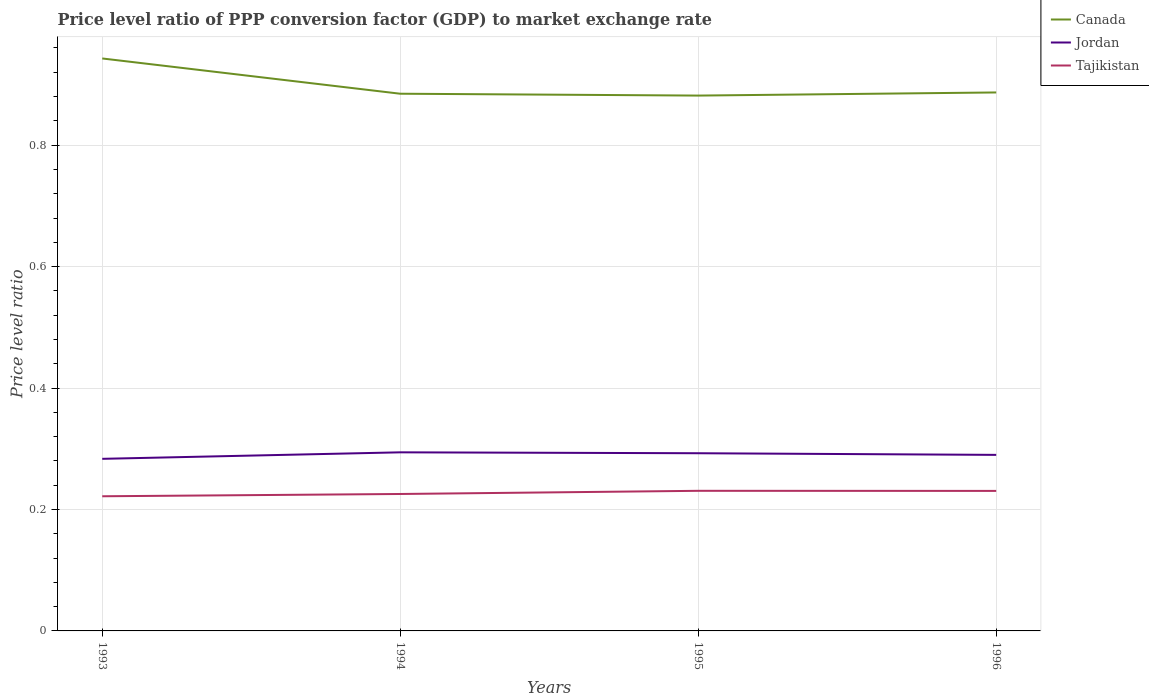Across all years, what is the maximum price level ratio in Jordan?
Your answer should be compact. 0.28. What is the total price level ratio in Canada in the graph?
Give a very brief answer. 0.06. What is the difference between the highest and the second highest price level ratio in Canada?
Offer a very short reply. 0.06. What is the difference between the highest and the lowest price level ratio in Canada?
Offer a very short reply. 1. How many lines are there?
Give a very brief answer. 3. How many years are there in the graph?
Provide a succinct answer. 4. What is the difference between two consecutive major ticks on the Y-axis?
Offer a very short reply. 0.2. Are the values on the major ticks of Y-axis written in scientific E-notation?
Provide a short and direct response. No. Where does the legend appear in the graph?
Give a very brief answer. Top right. How many legend labels are there?
Make the answer very short. 3. What is the title of the graph?
Your answer should be very brief. Price level ratio of PPP conversion factor (GDP) to market exchange rate. What is the label or title of the Y-axis?
Offer a terse response. Price level ratio. What is the Price level ratio in Canada in 1993?
Give a very brief answer. 0.94. What is the Price level ratio of Jordan in 1993?
Offer a terse response. 0.28. What is the Price level ratio of Tajikistan in 1993?
Provide a succinct answer. 0.22. What is the Price level ratio of Canada in 1994?
Your response must be concise. 0.88. What is the Price level ratio in Jordan in 1994?
Provide a short and direct response. 0.29. What is the Price level ratio of Tajikistan in 1994?
Offer a very short reply. 0.23. What is the Price level ratio in Canada in 1995?
Your answer should be very brief. 0.88. What is the Price level ratio of Jordan in 1995?
Make the answer very short. 0.29. What is the Price level ratio in Tajikistan in 1995?
Provide a short and direct response. 0.23. What is the Price level ratio in Canada in 1996?
Provide a succinct answer. 0.89. What is the Price level ratio in Jordan in 1996?
Give a very brief answer. 0.29. What is the Price level ratio in Tajikistan in 1996?
Provide a succinct answer. 0.23. Across all years, what is the maximum Price level ratio in Canada?
Provide a short and direct response. 0.94. Across all years, what is the maximum Price level ratio in Jordan?
Offer a very short reply. 0.29. Across all years, what is the maximum Price level ratio in Tajikistan?
Ensure brevity in your answer.  0.23. Across all years, what is the minimum Price level ratio in Canada?
Offer a very short reply. 0.88. Across all years, what is the minimum Price level ratio in Jordan?
Provide a short and direct response. 0.28. Across all years, what is the minimum Price level ratio of Tajikistan?
Your answer should be very brief. 0.22. What is the total Price level ratio in Canada in the graph?
Your answer should be compact. 3.6. What is the total Price level ratio of Jordan in the graph?
Your answer should be very brief. 1.16. What is the total Price level ratio of Tajikistan in the graph?
Your answer should be compact. 0.91. What is the difference between the Price level ratio in Canada in 1993 and that in 1994?
Offer a very short reply. 0.06. What is the difference between the Price level ratio in Jordan in 1993 and that in 1994?
Your answer should be very brief. -0.01. What is the difference between the Price level ratio in Tajikistan in 1993 and that in 1994?
Offer a terse response. -0. What is the difference between the Price level ratio of Canada in 1993 and that in 1995?
Your answer should be compact. 0.06. What is the difference between the Price level ratio of Jordan in 1993 and that in 1995?
Make the answer very short. -0.01. What is the difference between the Price level ratio in Tajikistan in 1993 and that in 1995?
Your answer should be very brief. -0.01. What is the difference between the Price level ratio in Canada in 1993 and that in 1996?
Offer a very short reply. 0.06. What is the difference between the Price level ratio of Jordan in 1993 and that in 1996?
Offer a terse response. -0.01. What is the difference between the Price level ratio in Tajikistan in 1993 and that in 1996?
Make the answer very short. -0.01. What is the difference between the Price level ratio of Canada in 1994 and that in 1995?
Provide a short and direct response. 0. What is the difference between the Price level ratio in Jordan in 1994 and that in 1995?
Give a very brief answer. 0. What is the difference between the Price level ratio of Tajikistan in 1994 and that in 1995?
Provide a succinct answer. -0.01. What is the difference between the Price level ratio in Canada in 1994 and that in 1996?
Provide a short and direct response. -0. What is the difference between the Price level ratio in Jordan in 1994 and that in 1996?
Provide a succinct answer. 0. What is the difference between the Price level ratio in Tajikistan in 1994 and that in 1996?
Your answer should be very brief. -0.01. What is the difference between the Price level ratio of Canada in 1995 and that in 1996?
Give a very brief answer. -0.01. What is the difference between the Price level ratio of Jordan in 1995 and that in 1996?
Your response must be concise. 0. What is the difference between the Price level ratio of Tajikistan in 1995 and that in 1996?
Provide a succinct answer. 0. What is the difference between the Price level ratio in Canada in 1993 and the Price level ratio in Jordan in 1994?
Give a very brief answer. 0.65. What is the difference between the Price level ratio in Canada in 1993 and the Price level ratio in Tajikistan in 1994?
Keep it short and to the point. 0.72. What is the difference between the Price level ratio of Jordan in 1993 and the Price level ratio of Tajikistan in 1994?
Provide a short and direct response. 0.06. What is the difference between the Price level ratio of Canada in 1993 and the Price level ratio of Jordan in 1995?
Your answer should be compact. 0.65. What is the difference between the Price level ratio of Canada in 1993 and the Price level ratio of Tajikistan in 1995?
Your response must be concise. 0.71. What is the difference between the Price level ratio of Jordan in 1993 and the Price level ratio of Tajikistan in 1995?
Keep it short and to the point. 0.05. What is the difference between the Price level ratio in Canada in 1993 and the Price level ratio in Jordan in 1996?
Your response must be concise. 0.65. What is the difference between the Price level ratio of Canada in 1993 and the Price level ratio of Tajikistan in 1996?
Your response must be concise. 0.71. What is the difference between the Price level ratio in Jordan in 1993 and the Price level ratio in Tajikistan in 1996?
Your answer should be very brief. 0.05. What is the difference between the Price level ratio of Canada in 1994 and the Price level ratio of Jordan in 1995?
Offer a terse response. 0.59. What is the difference between the Price level ratio in Canada in 1994 and the Price level ratio in Tajikistan in 1995?
Provide a short and direct response. 0.65. What is the difference between the Price level ratio of Jordan in 1994 and the Price level ratio of Tajikistan in 1995?
Your answer should be very brief. 0.06. What is the difference between the Price level ratio in Canada in 1994 and the Price level ratio in Jordan in 1996?
Your response must be concise. 0.59. What is the difference between the Price level ratio of Canada in 1994 and the Price level ratio of Tajikistan in 1996?
Provide a short and direct response. 0.65. What is the difference between the Price level ratio of Jordan in 1994 and the Price level ratio of Tajikistan in 1996?
Provide a short and direct response. 0.06. What is the difference between the Price level ratio in Canada in 1995 and the Price level ratio in Jordan in 1996?
Make the answer very short. 0.59. What is the difference between the Price level ratio of Canada in 1995 and the Price level ratio of Tajikistan in 1996?
Your response must be concise. 0.65. What is the difference between the Price level ratio in Jordan in 1995 and the Price level ratio in Tajikistan in 1996?
Provide a succinct answer. 0.06. What is the average Price level ratio of Canada per year?
Your answer should be compact. 0.9. What is the average Price level ratio in Jordan per year?
Make the answer very short. 0.29. What is the average Price level ratio in Tajikistan per year?
Your response must be concise. 0.23. In the year 1993, what is the difference between the Price level ratio in Canada and Price level ratio in Jordan?
Offer a terse response. 0.66. In the year 1993, what is the difference between the Price level ratio of Canada and Price level ratio of Tajikistan?
Ensure brevity in your answer.  0.72. In the year 1993, what is the difference between the Price level ratio of Jordan and Price level ratio of Tajikistan?
Offer a terse response. 0.06. In the year 1994, what is the difference between the Price level ratio of Canada and Price level ratio of Jordan?
Provide a short and direct response. 0.59. In the year 1994, what is the difference between the Price level ratio in Canada and Price level ratio in Tajikistan?
Your answer should be compact. 0.66. In the year 1994, what is the difference between the Price level ratio of Jordan and Price level ratio of Tajikistan?
Your answer should be compact. 0.07. In the year 1995, what is the difference between the Price level ratio in Canada and Price level ratio in Jordan?
Keep it short and to the point. 0.59. In the year 1995, what is the difference between the Price level ratio of Canada and Price level ratio of Tajikistan?
Offer a very short reply. 0.65. In the year 1995, what is the difference between the Price level ratio in Jordan and Price level ratio in Tajikistan?
Your answer should be compact. 0.06. In the year 1996, what is the difference between the Price level ratio in Canada and Price level ratio in Jordan?
Provide a short and direct response. 0.6. In the year 1996, what is the difference between the Price level ratio of Canada and Price level ratio of Tajikistan?
Ensure brevity in your answer.  0.66. In the year 1996, what is the difference between the Price level ratio in Jordan and Price level ratio in Tajikistan?
Your response must be concise. 0.06. What is the ratio of the Price level ratio in Canada in 1993 to that in 1994?
Your response must be concise. 1.07. What is the ratio of the Price level ratio in Jordan in 1993 to that in 1994?
Offer a terse response. 0.96. What is the ratio of the Price level ratio of Tajikistan in 1993 to that in 1994?
Your answer should be very brief. 0.98. What is the ratio of the Price level ratio in Canada in 1993 to that in 1995?
Provide a short and direct response. 1.07. What is the ratio of the Price level ratio in Jordan in 1993 to that in 1995?
Offer a very short reply. 0.97. What is the ratio of the Price level ratio of Tajikistan in 1993 to that in 1995?
Provide a succinct answer. 0.96. What is the ratio of the Price level ratio of Canada in 1993 to that in 1996?
Make the answer very short. 1.06. What is the ratio of the Price level ratio in Jordan in 1993 to that in 1996?
Provide a succinct answer. 0.98. What is the ratio of the Price level ratio in Tajikistan in 1993 to that in 1996?
Provide a short and direct response. 0.96. What is the ratio of the Price level ratio in Canada in 1994 to that in 1995?
Your response must be concise. 1. What is the ratio of the Price level ratio of Jordan in 1994 to that in 1995?
Offer a very short reply. 1. What is the ratio of the Price level ratio of Tajikistan in 1994 to that in 1995?
Offer a very short reply. 0.98. What is the ratio of the Price level ratio in Jordan in 1994 to that in 1996?
Your answer should be compact. 1.01. What is the ratio of the Price level ratio of Tajikistan in 1994 to that in 1996?
Provide a succinct answer. 0.98. What is the ratio of the Price level ratio of Jordan in 1995 to that in 1996?
Give a very brief answer. 1.01. What is the ratio of the Price level ratio of Tajikistan in 1995 to that in 1996?
Your answer should be very brief. 1. What is the difference between the highest and the second highest Price level ratio in Canada?
Provide a short and direct response. 0.06. What is the difference between the highest and the second highest Price level ratio in Jordan?
Make the answer very short. 0. What is the difference between the highest and the second highest Price level ratio in Tajikistan?
Offer a very short reply. 0. What is the difference between the highest and the lowest Price level ratio in Canada?
Give a very brief answer. 0.06. What is the difference between the highest and the lowest Price level ratio of Jordan?
Provide a succinct answer. 0.01. What is the difference between the highest and the lowest Price level ratio in Tajikistan?
Keep it short and to the point. 0.01. 